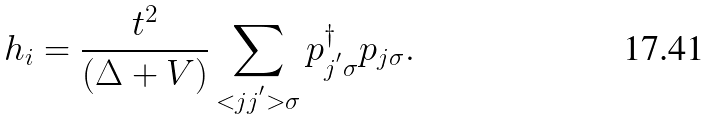<formula> <loc_0><loc_0><loc_500><loc_500>h _ { i } = \frac { t ^ { 2 } } { ( \Delta + V ) } \sum _ { < j j ^ { ^ { \prime } } > \sigma } p ^ { \dagger } _ { j ^ { ^ { \prime } } \sigma } p _ { j \sigma } .</formula> 